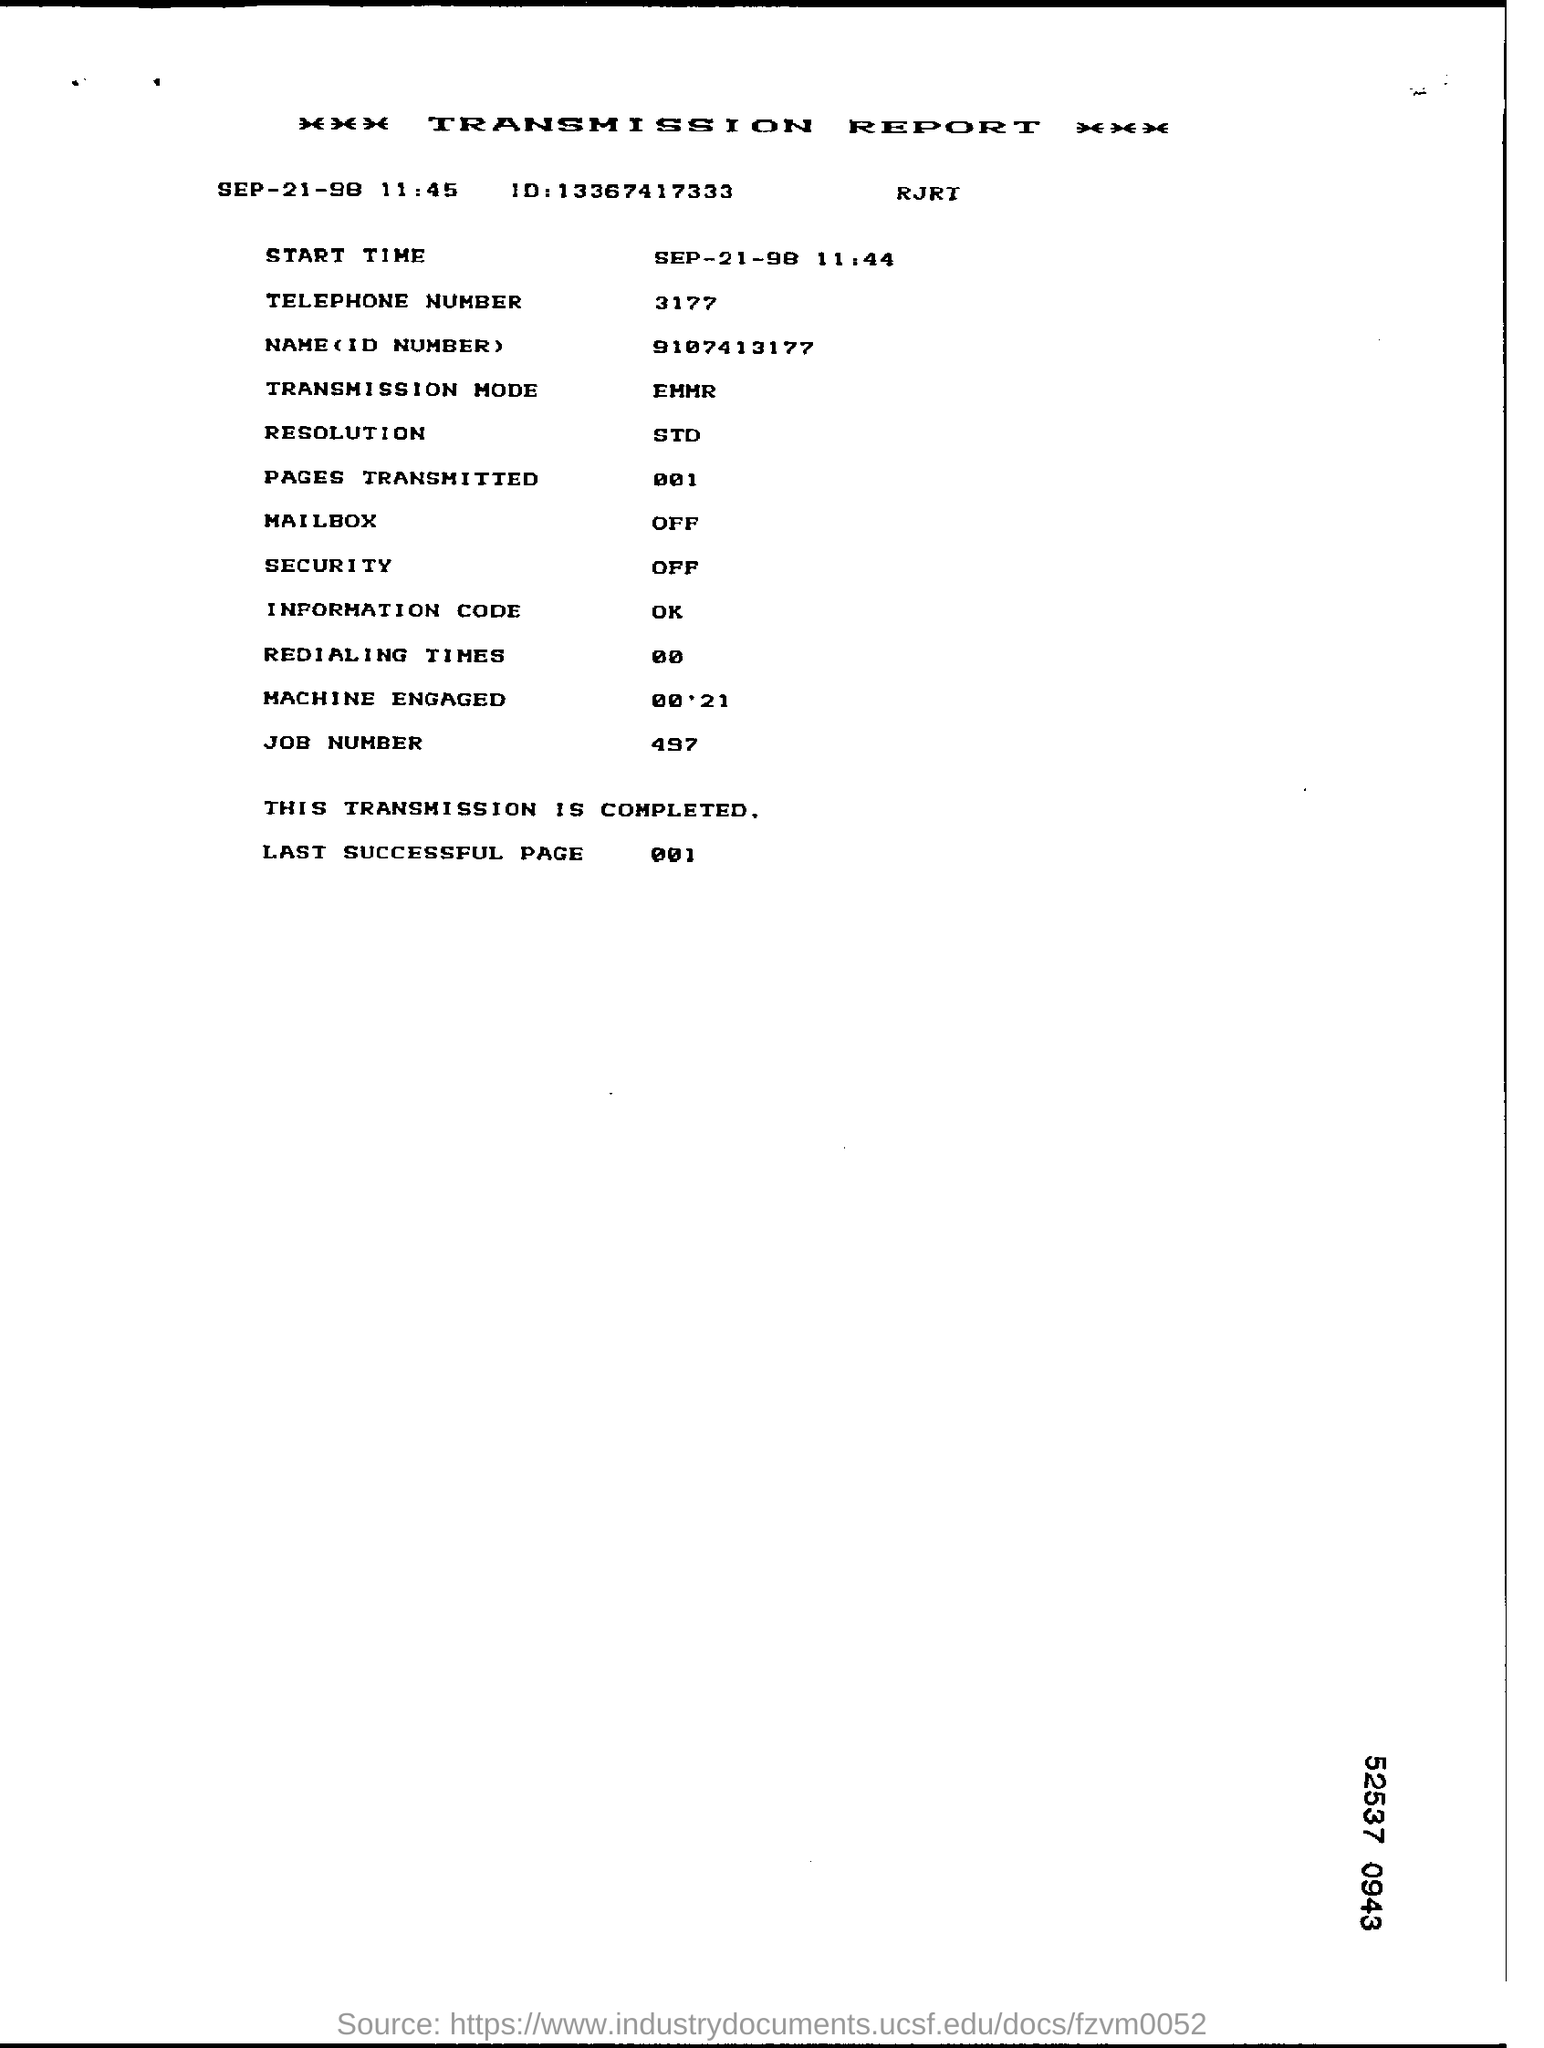what is the last successful page number as per report
 001 